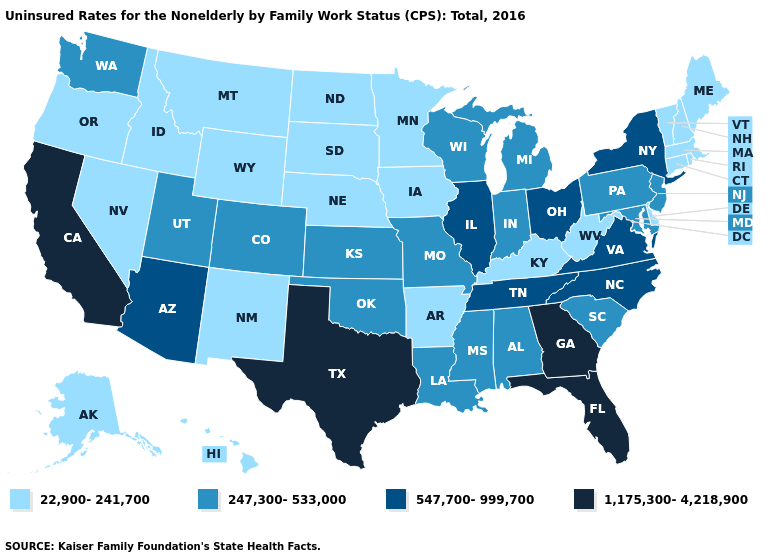What is the lowest value in the USA?
Answer briefly. 22,900-241,700. Which states have the lowest value in the Northeast?
Give a very brief answer. Connecticut, Maine, Massachusetts, New Hampshire, Rhode Island, Vermont. Does the map have missing data?
Be succinct. No. Does California have the lowest value in the USA?
Write a very short answer. No. What is the highest value in the South ?
Give a very brief answer. 1,175,300-4,218,900. Among the states that border New Hampshire , which have the highest value?
Be succinct. Maine, Massachusetts, Vermont. What is the value of Pennsylvania?
Keep it brief. 247,300-533,000. What is the value of North Carolina?
Quick response, please. 547,700-999,700. Among the states that border Alabama , which have the lowest value?
Keep it brief. Mississippi. Does California have the same value as Colorado?
Be succinct. No. What is the highest value in states that border Florida?
Short answer required. 1,175,300-4,218,900. Does the map have missing data?
Give a very brief answer. No. What is the value of Maine?
Keep it brief. 22,900-241,700. What is the value of California?
Quick response, please. 1,175,300-4,218,900. Does Virginia have a higher value than New Hampshire?
Answer briefly. Yes. 